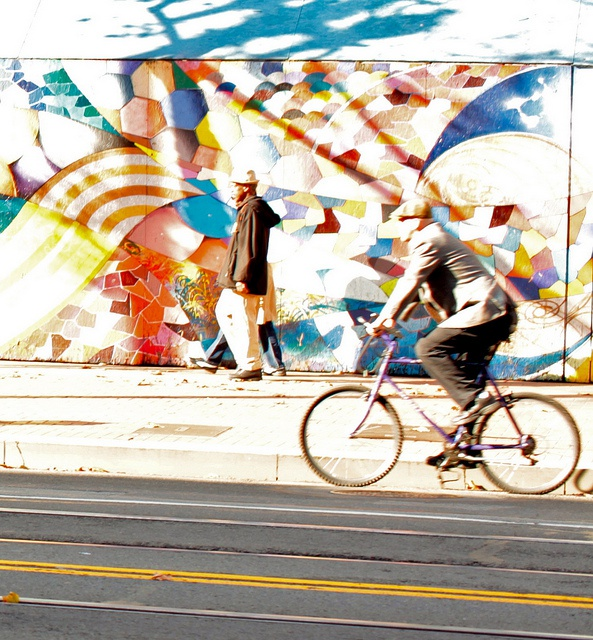Describe the objects in this image and their specific colors. I can see people in white, ivory, black, and gray tones, people in white, black, tan, and maroon tones, and people in white, black, tan, and orange tones in this image. 